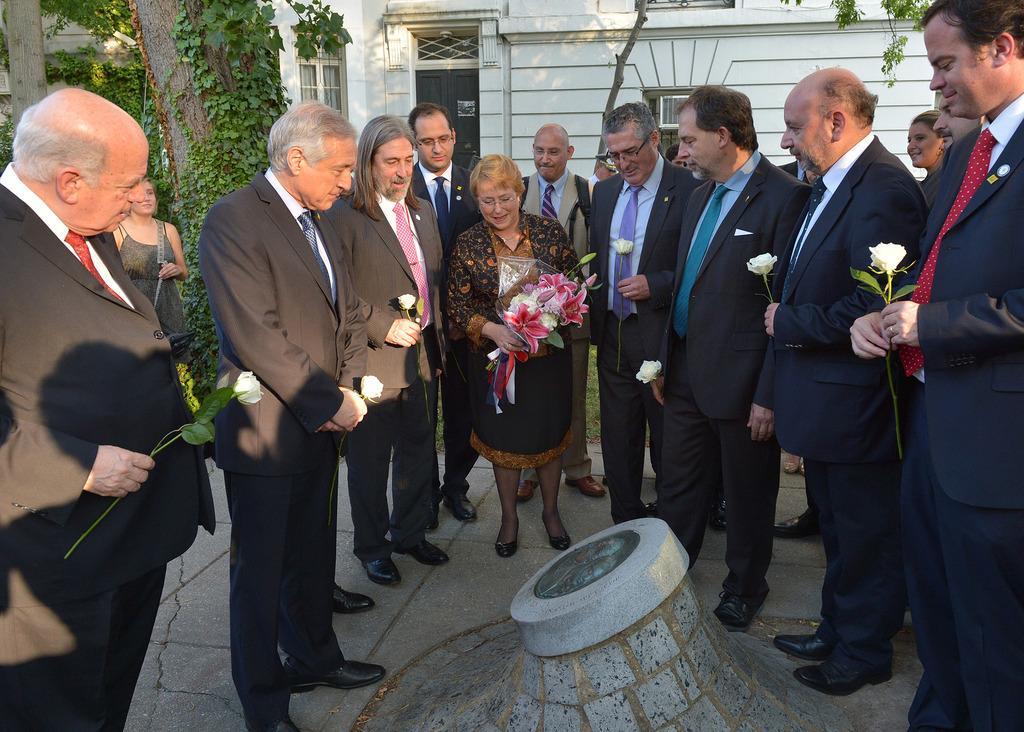Could you give a brief overview of what you see in this image? In the picture we can see some men and woman are standing around the grave stone and they are in blazers, ties and shirts and woman is holding some flower and men are also holding one flower in their hands and behind them, we can see a tree with creepers to it and behind it we can see a house building with windows and door. 